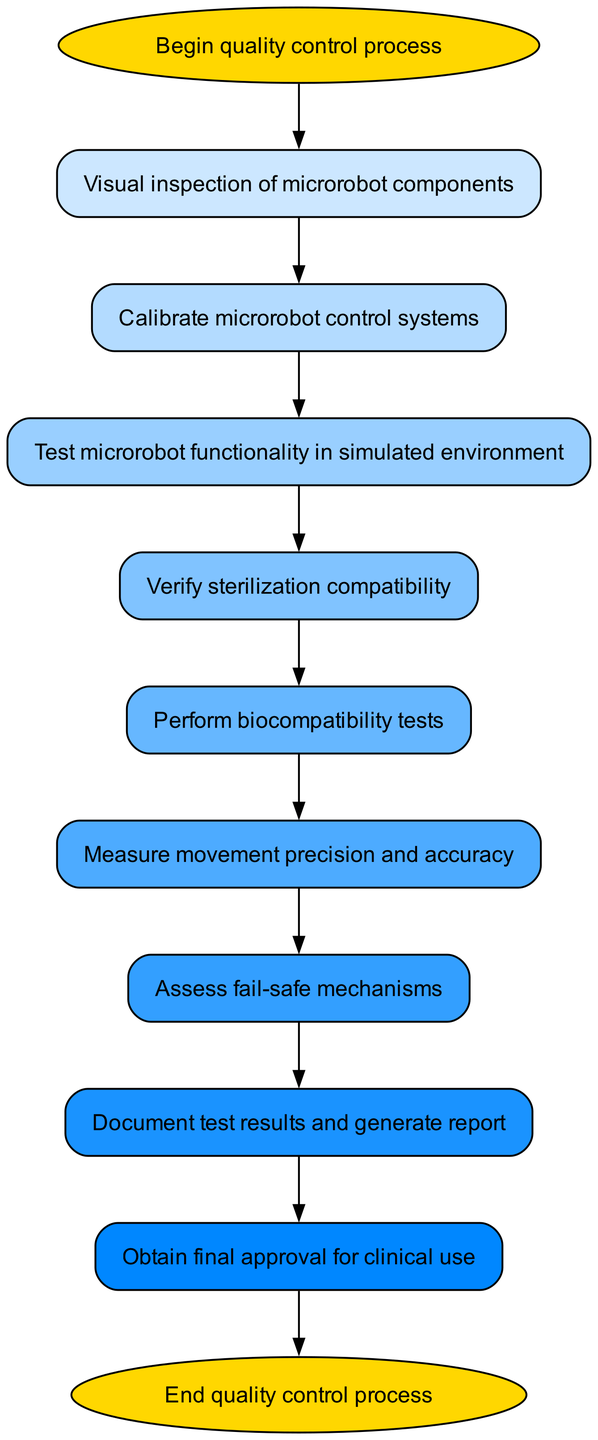What is the first step in the quality control process? The first step in the process, as indicated by the "start" node, is "Begin quality control process."
Answer: Begin quality control process How many total steps are there in the quality control process? By counting the nodes in the diagram, there are ten steps from "Begin quality control process" to "End quality control process," including all inspections and tests.
Answer: Ten What step follows "Calibration"? According to the diagram connections, after "Calibration," the next step is "Test microrobot functionality in simulated environment."
Answer: Test microrobot functionality in simulated environment What is the last step before obtaining final approval? The last step before "Obtain final approval for clinical use" is "Document test results and generate report." This is clear from the sequence of nodes leading to approval.
Answer: Document test results and generate report Which step assesses the safety mechanisms of the microrobot? The step that assesses safety mechanisms is "Assess fail-safe mechanisms." This is the node before the documentation of the test results.
Answer: Assess fail-safe mechanisms How many tests are conducted after verifying sterilization compatibility? After "Verify sterilization compatibility," there are two tests conducted: "Perform biocompatibility tests" and then "Measure movement precision and accuracy."
Answer: Two What is the relationship between "Visual inspection of microrobot components" and "Calibration"? The relationship is sequential; "Visual inspection of microrobot components" leads directly to "Calibrate microrobot control systems," demonstrating that calibration occurs after inspection.
Answer: Directly leads to Is "Begin quality control process" an endpoint? No, "Begin quality control process" is the starting point and not an endpoint, as the endpoint is labeled "End quality control process."
Answer: No 